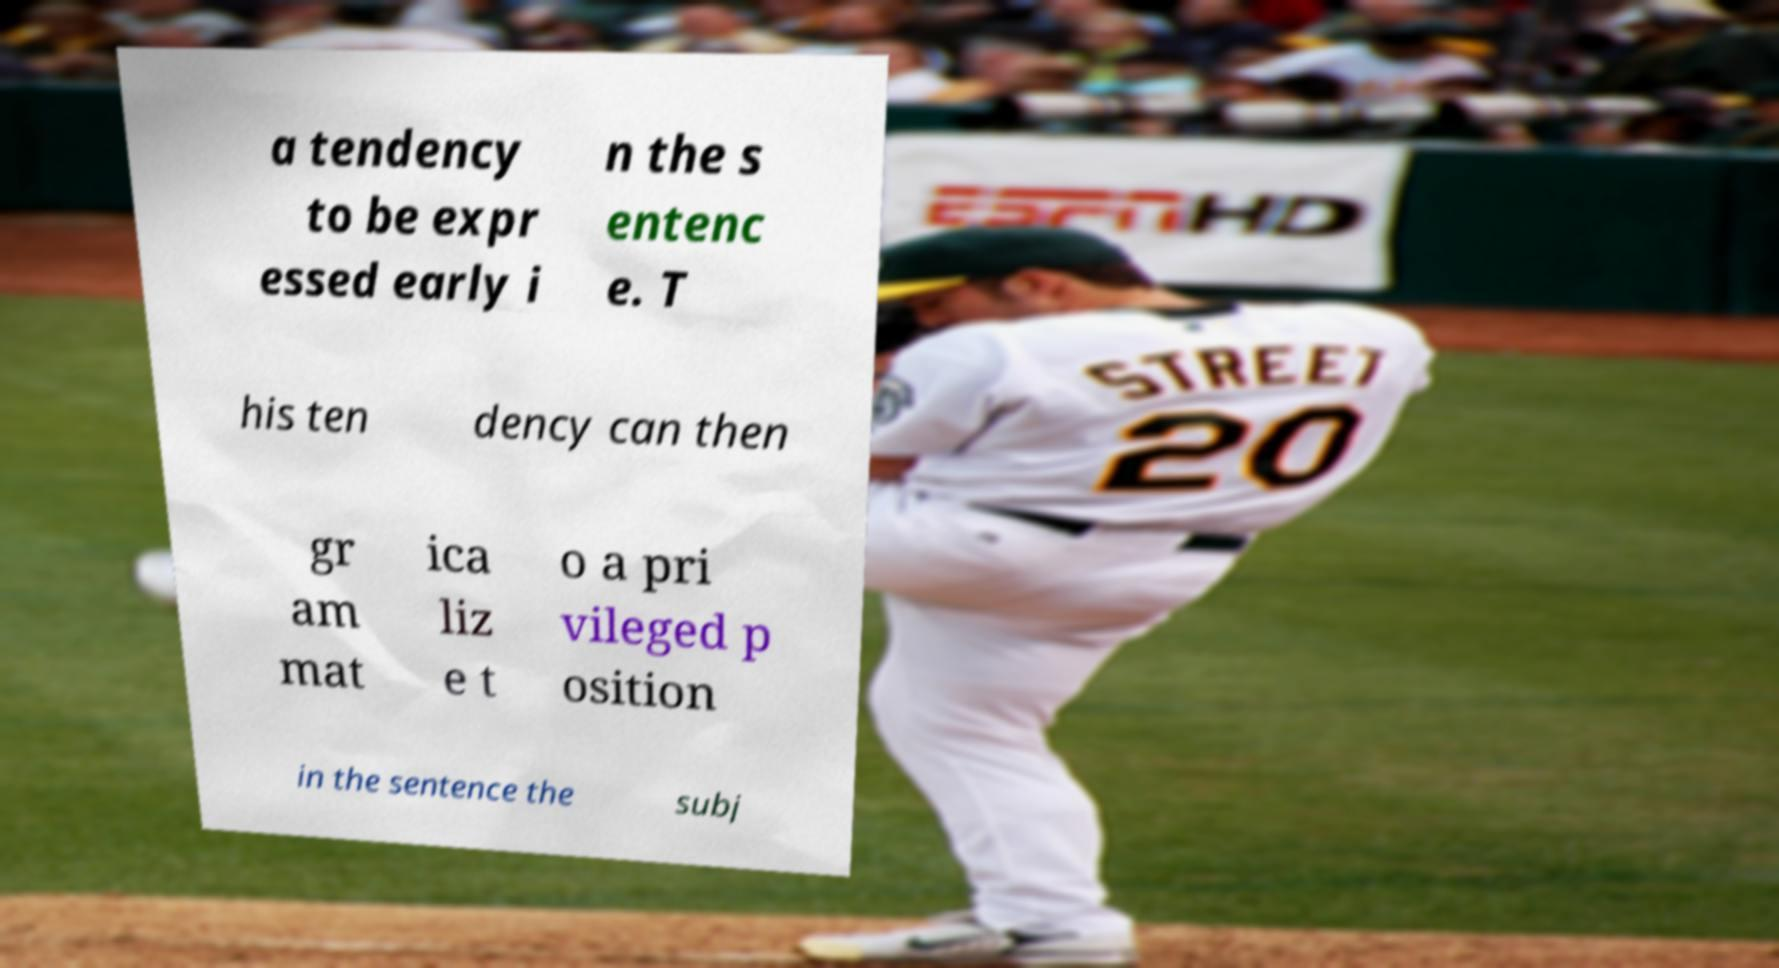What messages or text are displayed in this image? I need them in a readable, typed format. a tendency to be expr essed early i n the s entenc e. T his ten dency can then gr am mat ica liz e t o a pri vileged p osition in the sentence the subj 